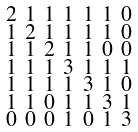Convert formula to latex. <formula><loc_0><loc_0><loc_500><loc_500>\begin{smallmatrix} 2 & 1 & 1 & 1 & 1 & 1 & 0 \\ 1 & 2 & 1 & 1 & 1 & 1 & 0 \\ 1 & 1 & 2 & 1 & 1 & 0 & 0 \\ 1 & 1 & 1 & 3 & 1 & 1 & 1 \\ 1 & 1 & 1 & 1 & 3 & 1 & 0 \\ 1 & 1 & 0 & 1 & 1 & 3 & 1 \\ 0 & 0 & 0 & 1 & 0 & 1 & 3 \end{smallmatrix}</formula> 